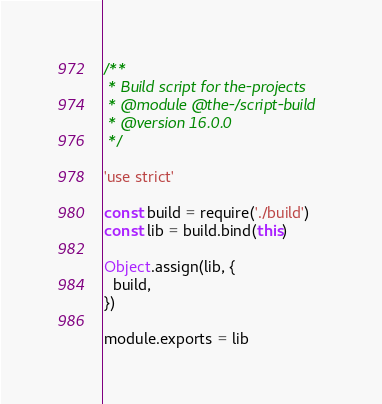Convert code to text. <code><loc_0><loc_0><loc_500><loc_500><_JavaScript_>/**
 * Build script for the-projects
 * @module @the-/script-build
 * @version 16.0.0
 */

'use strict'

const build = require('./build')
const lib = build.bind(this)

Object.assign(lib, {
  build,
})

module.exports = lib
</code> 